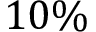<formula> <loc_0><loc_0><loc_500><loc_500>1 0 \%</formula> 